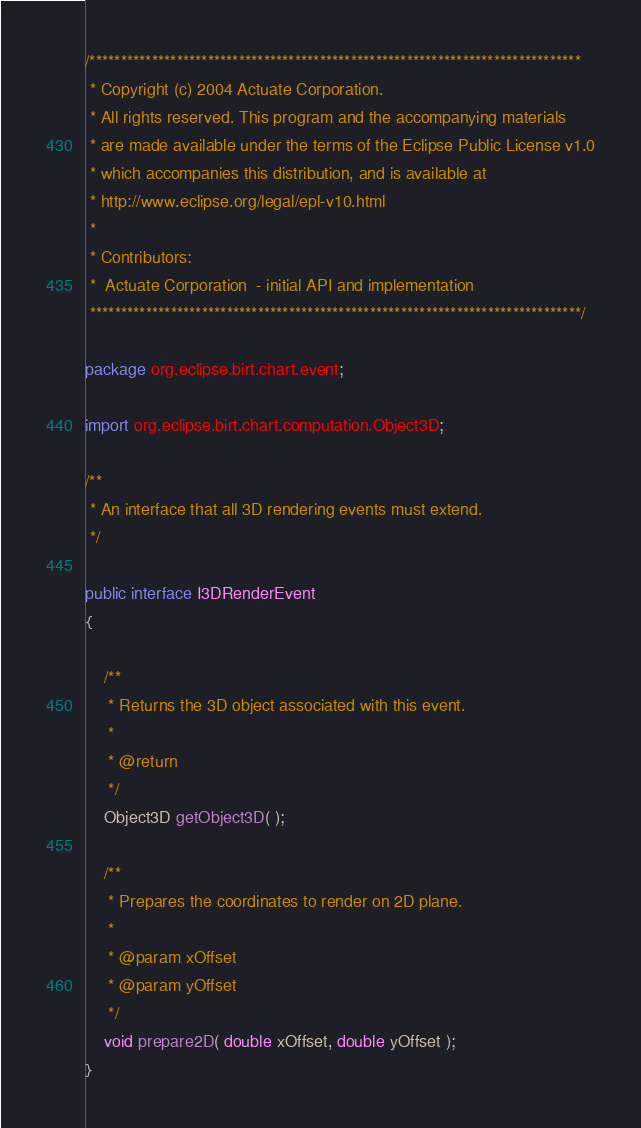<code> <loc_0><loc_0><loc_500><loc_500><_Java_>/*******************************************************************************
 * Copyright (c) 2004 Actuate Corporation.
 * All rights reserved. This program and the accompanying materials
 * are made available under the terms of the Eclipse Public License v1.0
 * which accompanies this distribution, and is available at
 * http://www.eclipse.org/legal/epl-v10.html
 *
 * Contributors:
 *  Actuate Corporation  - initial API and implementation
 *******************************************************************************/

package org.eclipse.birt.chart.event;

import org.eclipse.birt.chart.computation.Object3D;

/**
 * An interface that all 3D rendering events must extend.
 */

public interface I3DRenderEvent
{

	/**
	 * Returns the 3D object associated with this event.
	 * 
	 * @return
	 */
	Object3D getObject3D( );

	/**
	 * Prepares the coordinates to render on 2D plane.
	 * 
	 * @param xOffset
	 * @param yOffset
	 */
	void prepare2D( double xOffset, double yOffset );
}
</code> 